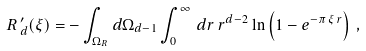<formula> <loc_0><loc_0><loc_500><loc_500>R \, ^ { \prime } _ { d } ( \xi ) = - \int _ { \Omega _ { R } } d \Omega _ { d - 1 } \int _ { 0 } ^ { \infty } \, d r \, r ^ { d - 2 } \ln \left ( 1 - e ^ { - \pi \, \xi \, r } \right ) \, ,</formula> 